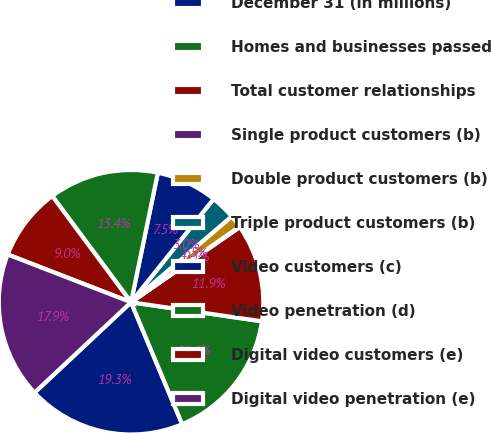<chart> <loc_0><loc_0><loc_500><loc_500><pie_chart><fcel>December 31 (in millions)<fcel>Homes and businesses passed<fcel>Total customer relationships<fcel>Single product customers (b)<fcel>Double product customers (b)<fcel>Triple product customers (b)<fcel>Video customers (c)<fcel>Video penetration (d)<fcel>Digital video customers (e)<fcel>Digital video penetration (e)<nl><fcel>19.34%<fcel>16.38%<fcel>11.93%<fcel>0.06%<fcel>1.55%<fcel>3.03%<fcel>7.48%<fcel>13.41%<fcel>8.96%<fcel>17.86%<nl></chart> 